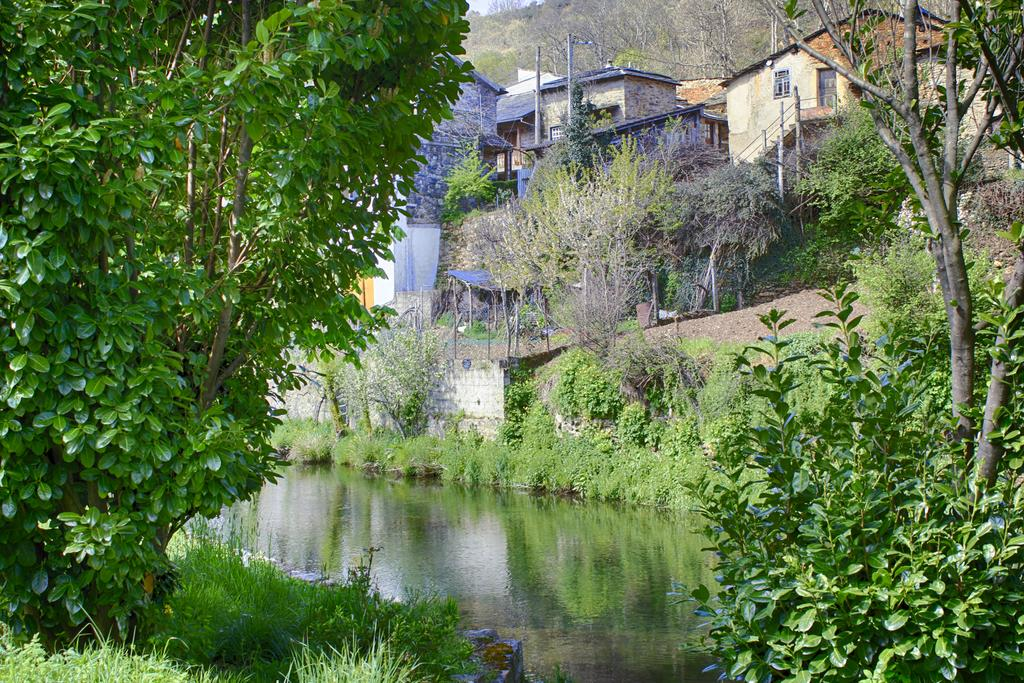What type of vegetation can be seen in the image? There are trees and plants visible in the image. What natural element is present in the image? There is water visible in the image. What type of ground cover is present in the image? There is grass in the image. What structures can be seen in the background of the image? There are buildings, poles, and a fence in the background of the image. Are there any other unspecified objects in the background of the image? Yes, there are other unspecified objects in the background of the image. What type of skin can be seen on the cattle in the image? There are no cattle present in the image, so there is no skin to observe. What type of plough is being used by the farmer in the image? There is no farmer or plough present in the image. 